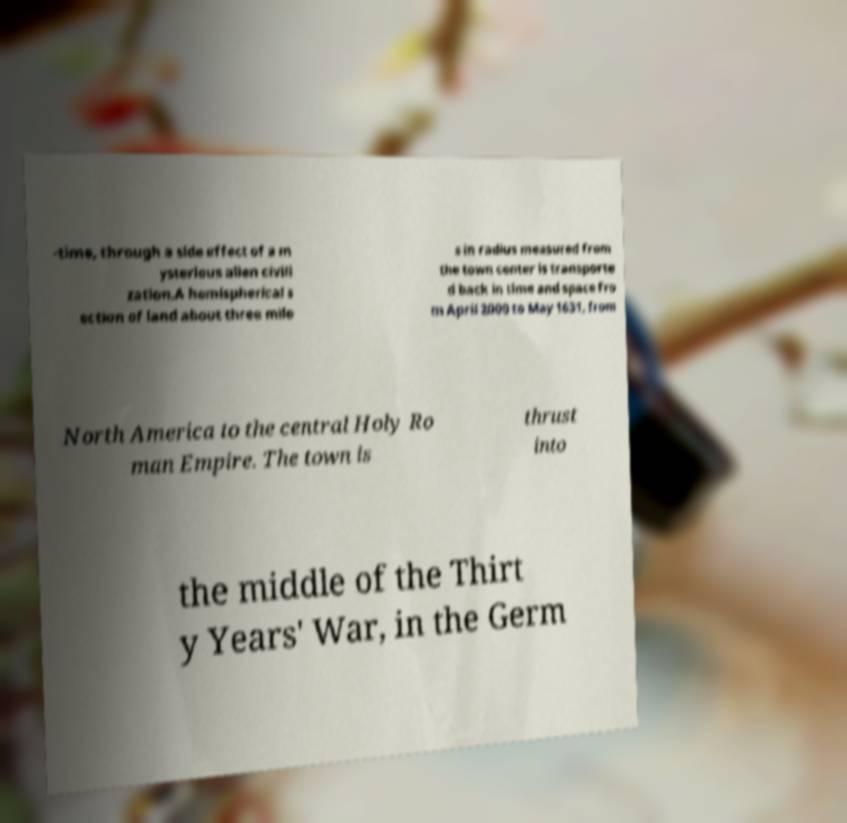Please read and relay the text visible in this image. What does it say? -time, through a side effect of a m ysterious alien civili zation.A hemispherical s ection of land about three mile s in radius measured from the town center is transporte d back in time and space fro m April 2000 to May 1631, from North America to the central Holy Ro man Empire. The town is thrust into the middle of the Thirt y Years' War, in the Germ 